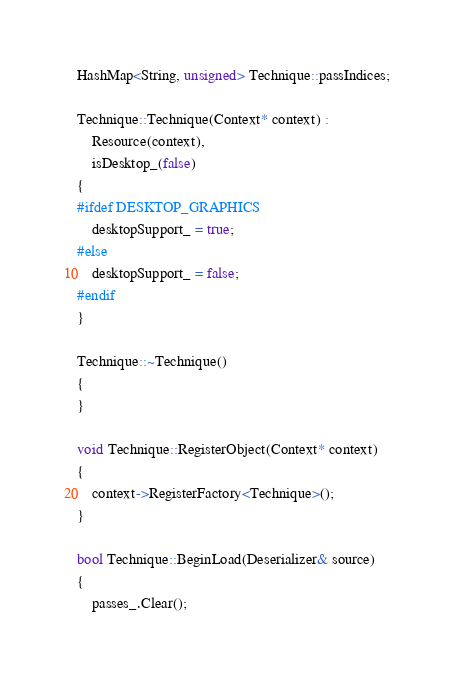<code> <loc_0><loc_0><loc_500><loc_500><_C++_>
HashMap<String, unsigned> Technique::passIndices;

Technique::Technique(Context* context) :
    Resource(context),
    isDesktop_(false)
{
#ifdef DESKTOP_GRAPHICS
    desktopSupport_ = true;
#else
    desktopSupport_ = false;
#endif
}

Technique::~Technique()
{
}

void Technique::RegisterObject(Context* context)
{
    context->RegisterFactory<Technique>();
}

bool Technique::BeginLoad(Deserializer& source)
{
    passes_.Clear();</code> 